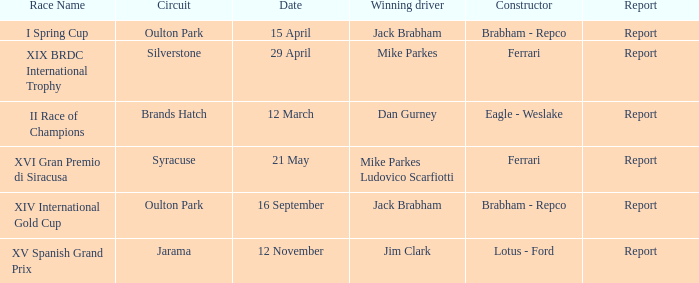What company constrcuted the vehicle with a circuit of oulton park on 15 april? Brabham - Repco. 